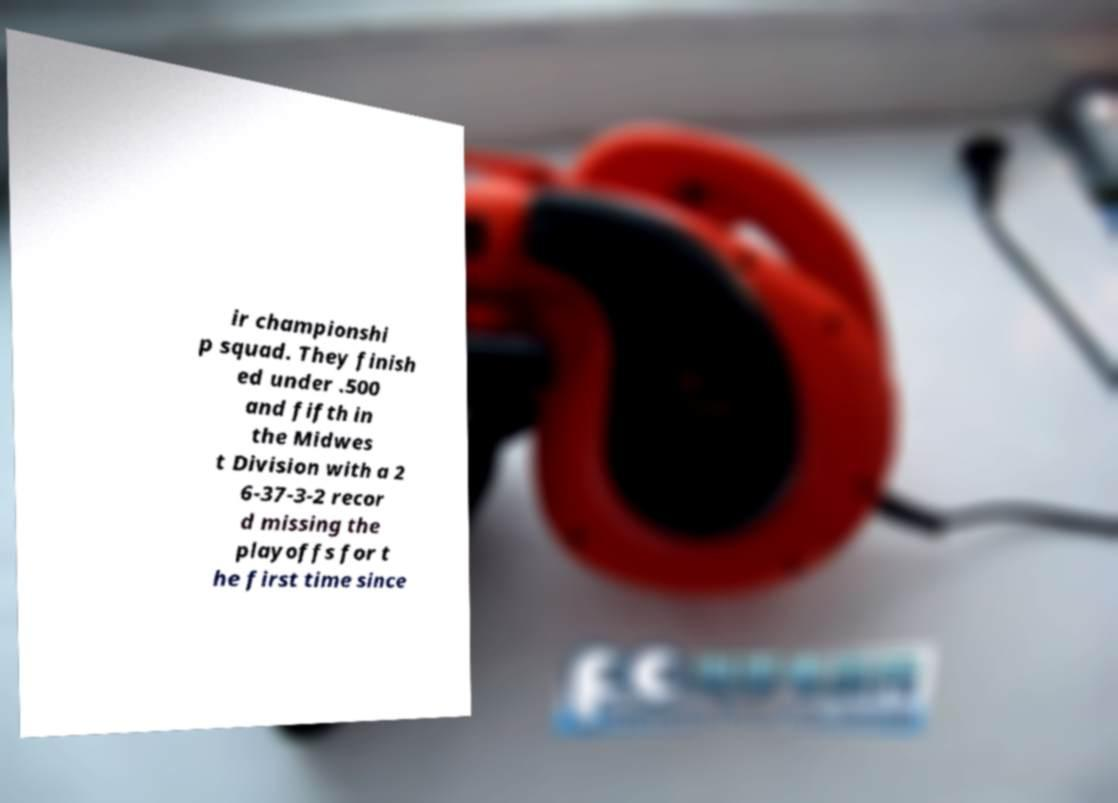For documentation purposes, I need the text within this image transcribed. Could you provide that? ir championshi p squad. They finish ed under .500 and fifth in the Midwes t Division with a 2 6-37-3-2 recor d missing the playoffs for t he first time since 